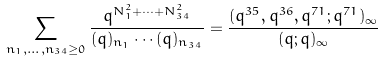<formula> <loc_0><loc_0><loc_500><loc_500>\sum _ { n _ { 1 } , \dots , n _ { 3 4 } \geq 0 } \frac { q ^ { N _ { 1 } ^ { 2 } + \cdots + N _ { 3 4 } ^ { 2 } } } { ( q ) _ { n _ { 1 } } \cdots ( q ) _ { n _ { 3 4 } } } = \frac { ( q ^ { 3 5 } , q ^ { 3 6 } , q ^ { 7 1 } ; q ^ { 7 1 } ) _ { \infty } } { ( q ; q ) _ { \infty } }</formula> 